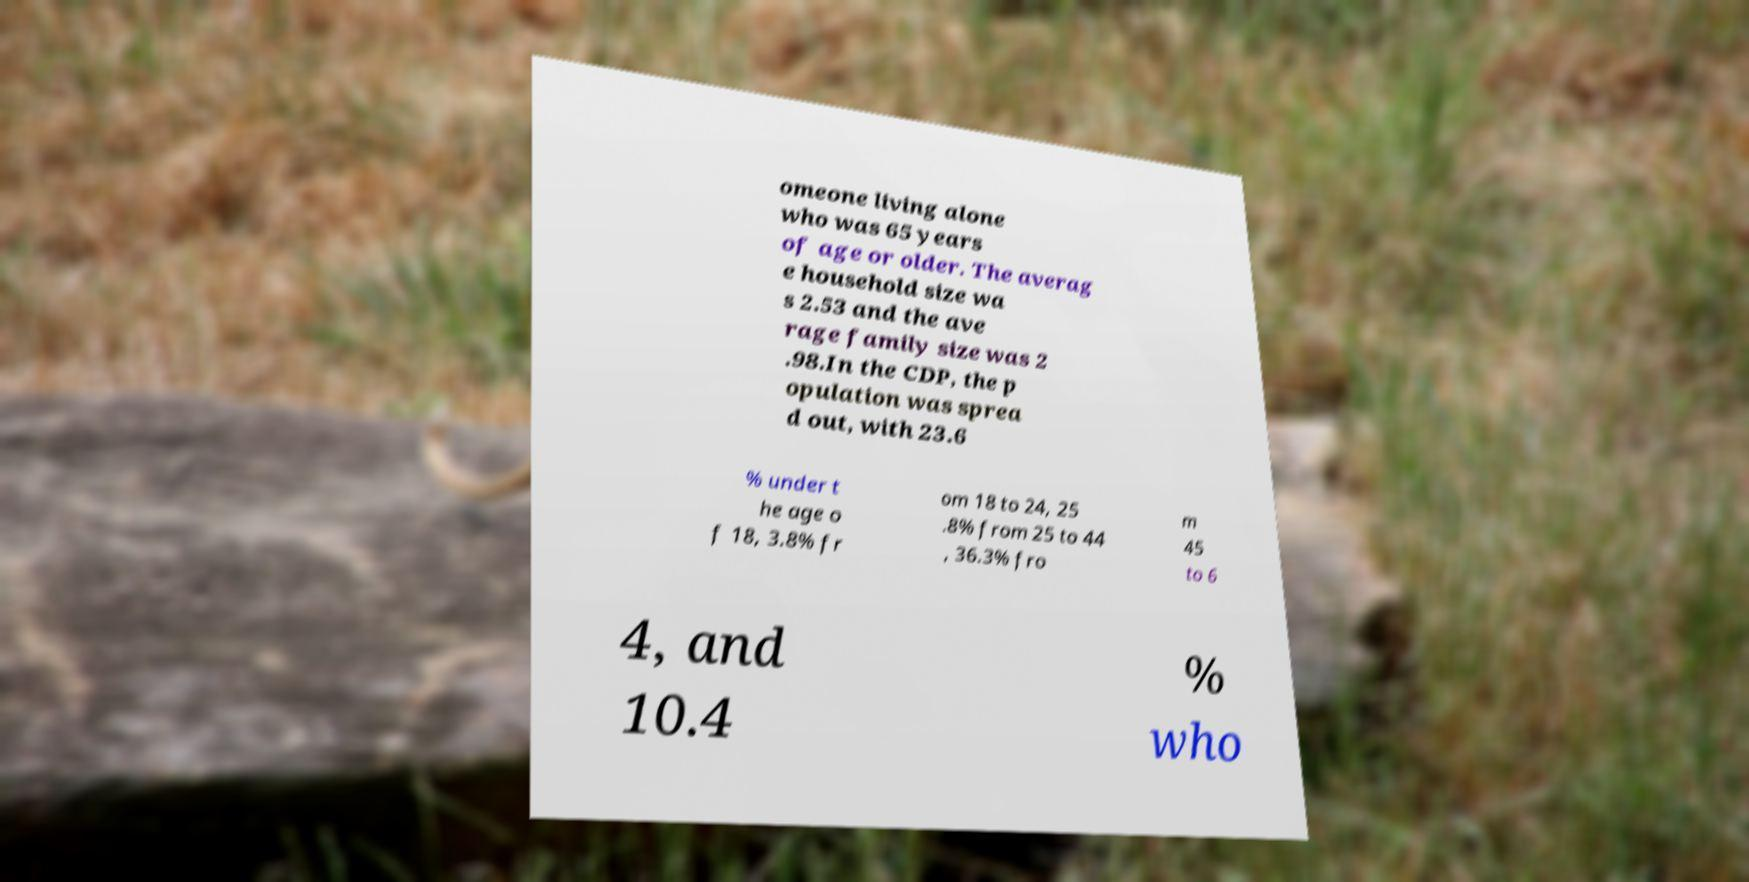For documentation purposes, I need the text within this image transcribed. Could you provide that? omeone living alone who was 65 years of age or older. The averag e household size wa s 2.53 and the ave rage family size was 2 .98.In the CDP, the p opulation was sprea d out, with 23.6 % under t he age o f 18, 3.8% fr om 18 to 24, 25 .8% from 25 to 44 , 36.3% fro m 45 to 6 4, and 10.4 % who 